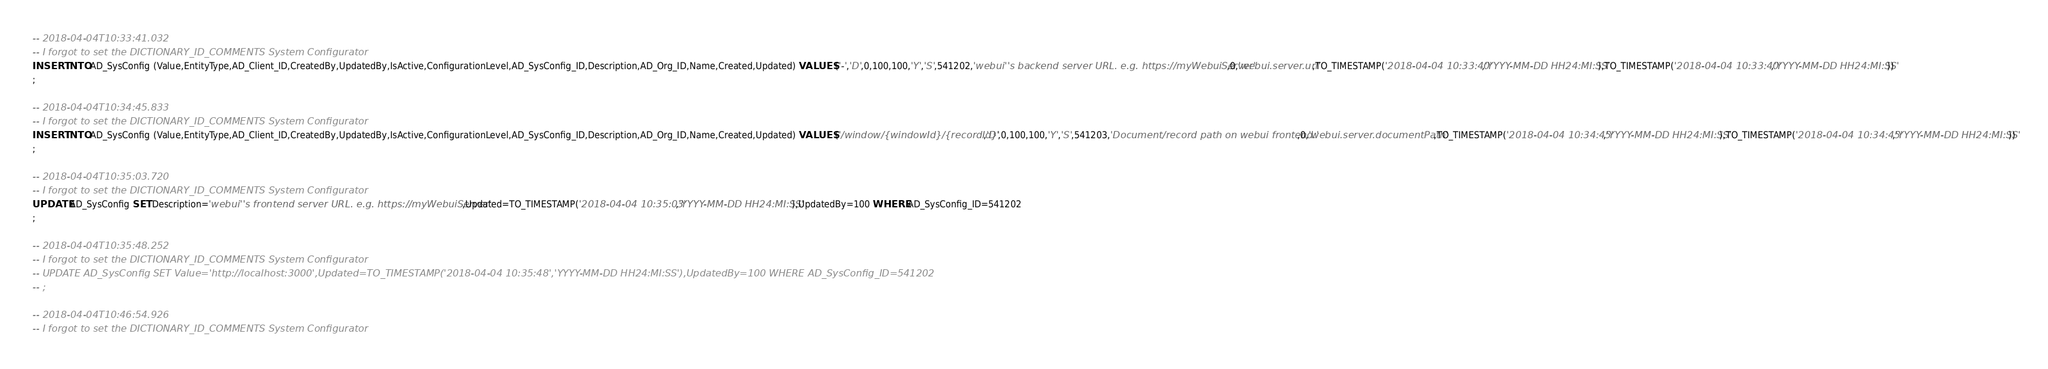<code> <loc_0><loc_0><loc_500><loc_500><_SQL_>-- 2018-04-04T10:33:41.032
-- I forgot to set the DICTIONARY_ID_COMMENTS System Configurator
INSERT INTO AD_SysConfig (Value,EntityType,AD_Client_ID,CreatedBy,UpdatedBy,IsActive,ConfigurationLevel,AD_SysConfig_ID,Description,AD_Org_ID,Name,Created,Updated) VALUES ('-','D',0,100,100,'Y','S',541202,'webui''s backend server URL. e.g. https://myWebuiServer',0,'webui.server.url',TO_TIMESTAMP('2018-04-04 10:33:40','YYYY-MM-DD HH24:MI:SS'),TO_TIMESTAMP('2018-04-04 10:33:40','YYYY-MM-DD HH24:MI:SS'))
;

-- 2018-04-04T10:34:45.833
-- I forgot to set the DICTIONARY_ID_COMMENTS System Configurator
INSERT INTO AD_SysConfig (Value,EntityType,AD_Client_ID,CreatedBy,UpdatedBy,IsActive,ConfigurationLevel,AD_SysConfig_ID,Description,AD_Org_ID,Name,Created,Updated) VALUES ('/window/{windowId}/{recordId}','D',0,100,100,'Y','S',541203,'Document/record path on webui frontend.',0,'webui.server.documentPath',TO_TIMESTAMP('2018-04-04 10:34:45','YYYY-MM-DD HH24:MI:SS'),TO_TIMESTAMP('2018-04-04 10:34:45','YYYY-MM-DD HH24:MI:SS'))
;

-- 2018-04-04T10:35:03.720
-- I forgot to set the DICTIONARY_ID_COMMENTS System Configurator
UPDATE AD_SysConfig SET Description='webui''s frontend server URL. e.g. https://myWebuiServer',Updated=TO_TIMESTAMP('2018-04-04 10:35:03','YYYY-MM-DD HH24:MI:SS'),UpdatedBy=100 WHERE AD_SysConfig_ID=541202
;

-- 2018-04-04T10:35:48.252
-- I forgot to set the DICTIONARY_ID_COMMENTS System Configurator
-- UPDATE AD_SysConfig SET Value='http://localhost:3000',Updated=TO_TIMESTAMP('2018-04-04 10:35:48','YYYY-MM-DD HH24:MI:SS'),UpdatedBy=100 WHERE AD_SysConfig_ID=541202
-- ;

-- 2018-04-04T10:46:54.926
-- I forgot to set the DICTIONARY_ID_COMMENTS System Configurator</code> 